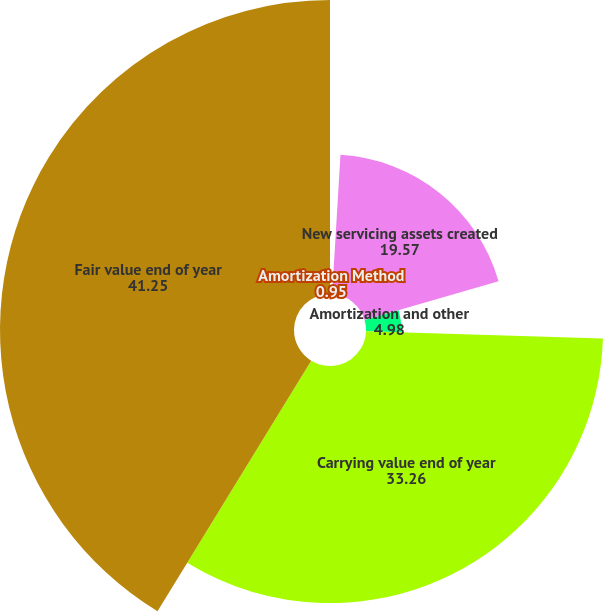Convert chart. <chart><loc_0><loc_0><loc_500><loc_500><pie_chart><fcel>Amortization Method<fcel>New servicing assets created<fcel>Amortization and other<fcel>Carrying value end of year<fcel>Fair value end of year<nl><fcel>0.95%<fcel>19.57%<fcel>4.98%<fcel>33.26%<fcel>41.25%<nl></chart> 